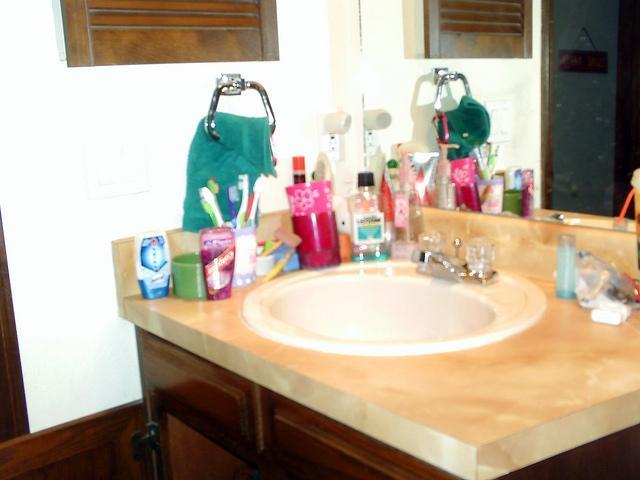How many bottles are in the photo?
Give a very brief answer. 2. How many apples are in the picture?
Give a very brief answer. 0. 